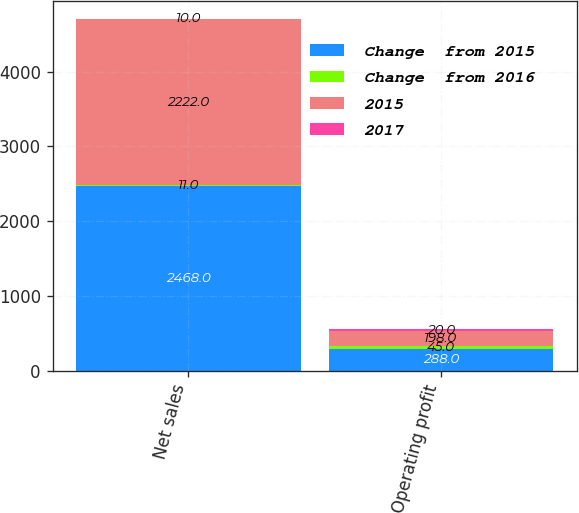<chart> <loc_0><loc_0><loc_500><loc_500><stacked_bar_chart><ecel><fcel>Net sales<fcel>Operating profit<nl><fcel>Change  from 2015<fcel>2468<fcel>288<nl><fcel>Change  from 2016<fcel>11<fcel>45<nl><fcel>2015<fcel>2222<fcel>198<nl><fcel>2017<fcel>10<fcel>20<nl></chart> 